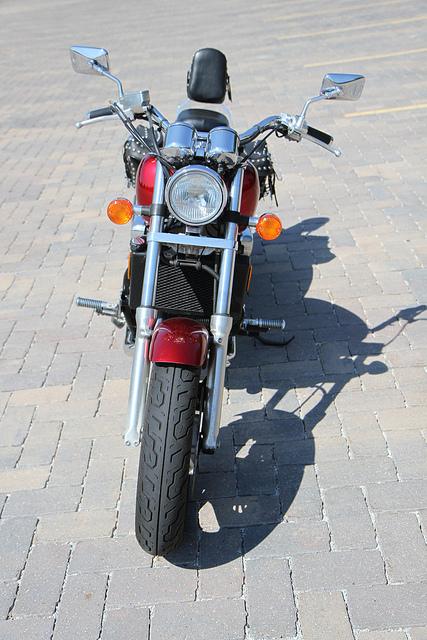Are the mirrors the same color as the seat?
Be succinct. No. Is the bike in the middle of the street?
Answer briefly. No. Is this motorcycle vintage?
Short answer required. No. 